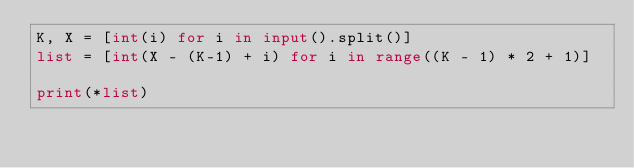Convert code to text. <code><loc_0><loc_0><loc_500><loc_500><_Python_>K, X = [int(i) for i in input().split()]
list = [int(X - (K-1) + i) for i in range((K - 1) * 2 + 1)]

print(*list)</code> 